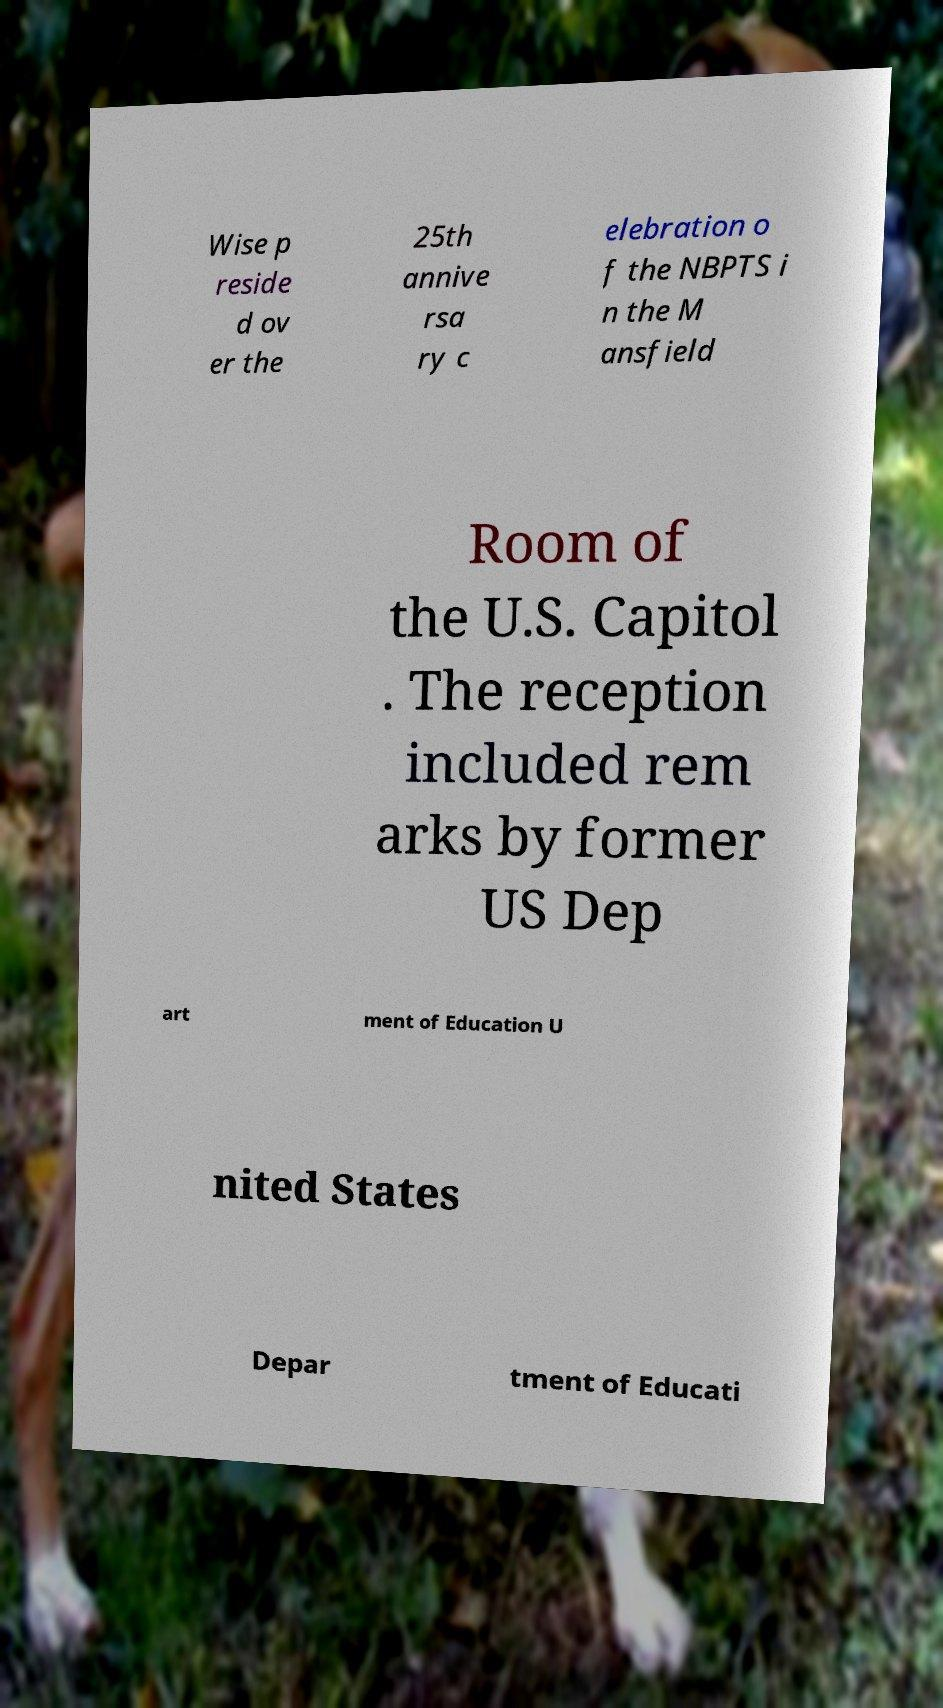There's text embedded in this image that I need extracted. Can you transcribe it verbatim? Wise p reside d ov er the 25th annive rsa ry c elebration o f the NBPTS i n the M ansfield Room of the U.S. Capitol . The reception included rem arks by former US Dep art ment of Education U nited States Depar tment of Educati 